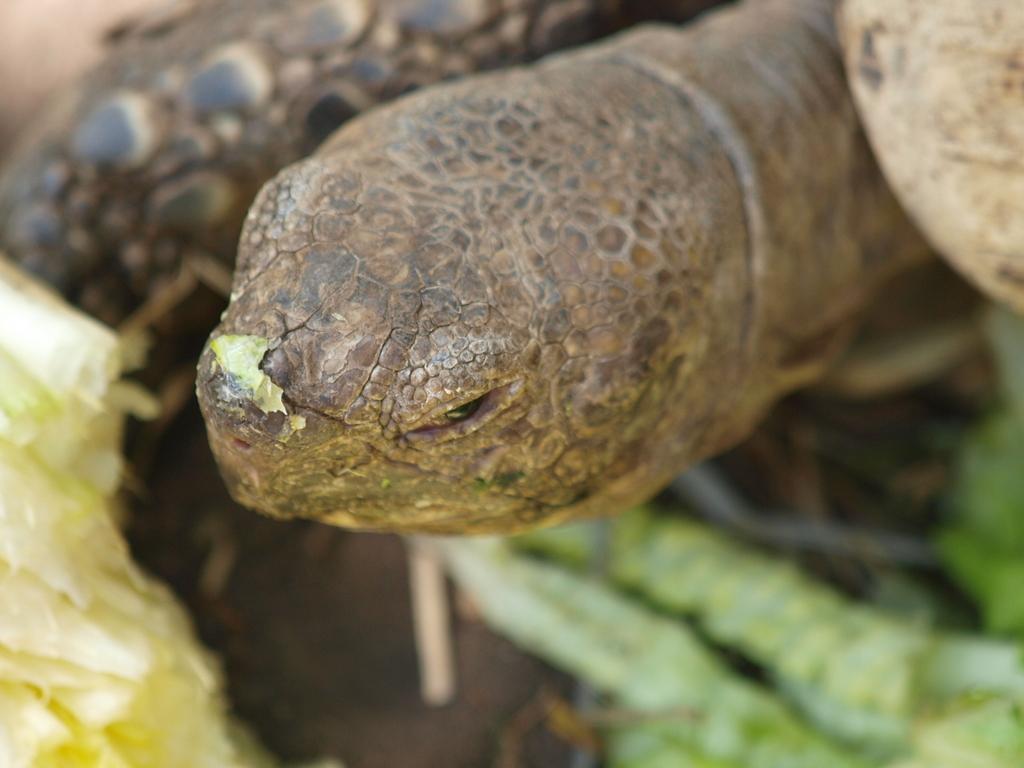Describe this image in one or two sentences. In this image I see a tortoise and I see the green color things over here and it is blurred a bit in the background. 